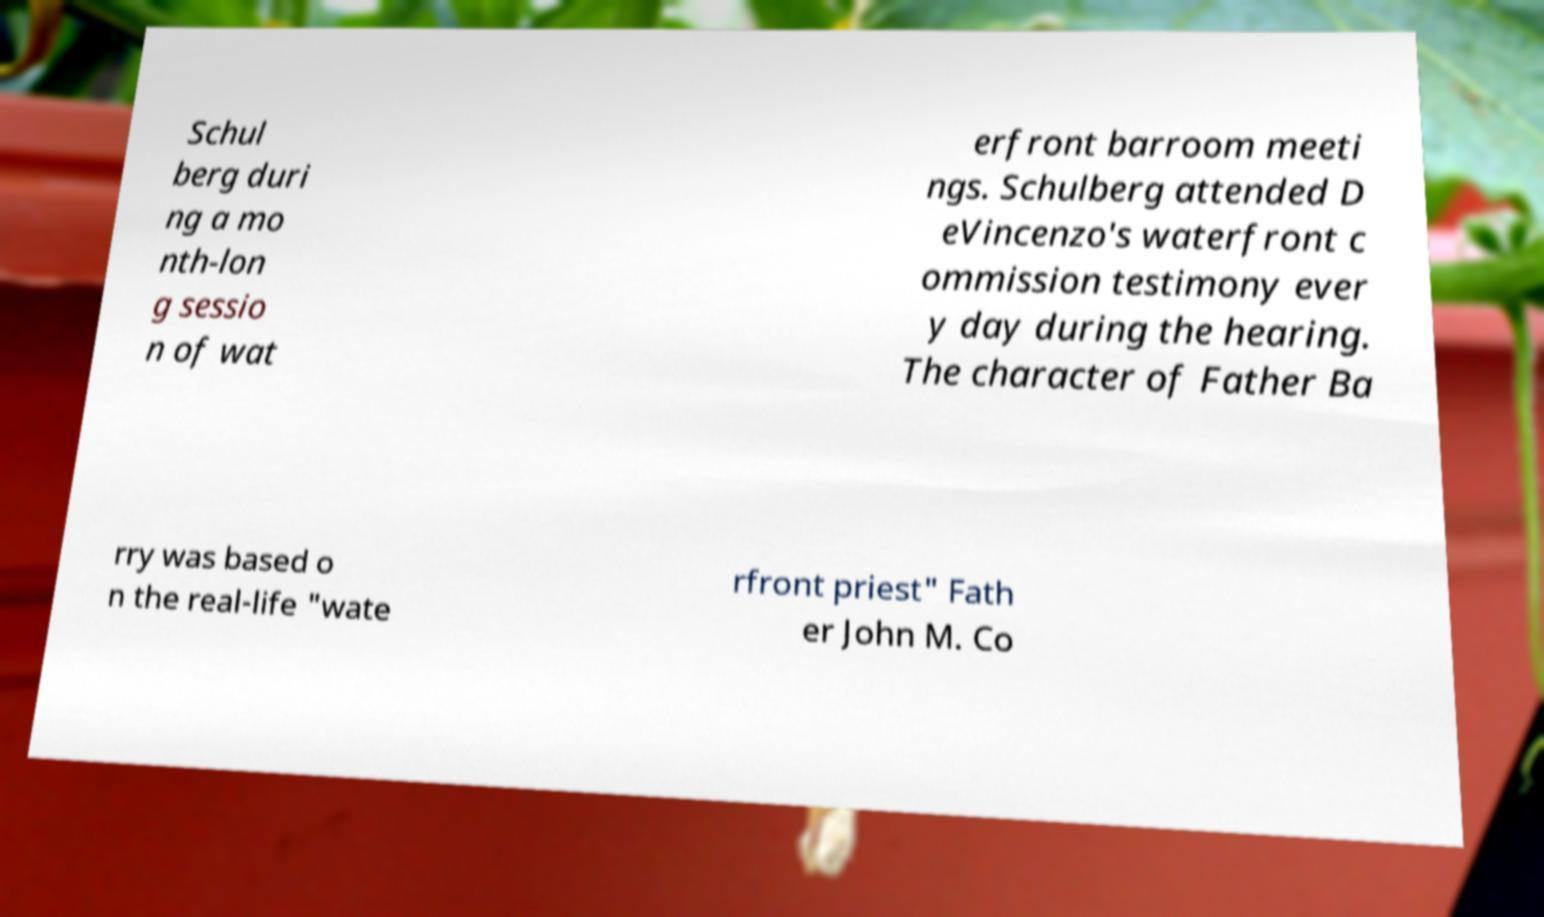For documentation purposes, I need the text within this image transcribed. Could you provide that? Schul berg duri ng a mo nth-lon g sessio n of wat erfront barroom meeti ngs. Schulberg attended D eVincenzo's waterfront c ommission testimony ever y day during the hearing. The character of Father Ba rry was based o n the real-life "wate rfront priest" Fath er John M. Co 